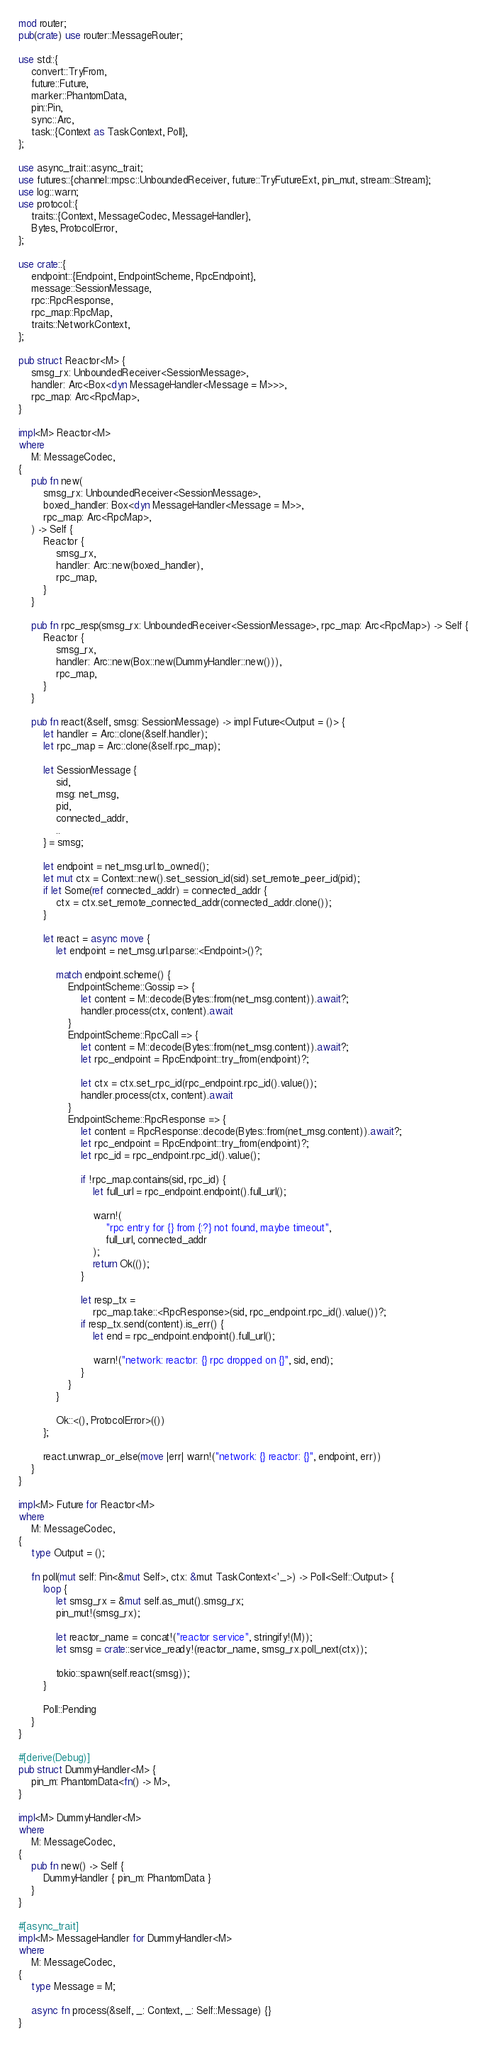Convert code to text. <code><loc_0><loc_0><loc_500><loc_500><_Rust_>mod router;
pub(crate) use router::MessageRouter;

use std::{
    convert::TryFrom,
    future::Future,
    marker::PhantomData,
    pin::Pin,
    sync::Arc,
    task::{Context as TaskContext, Poll},
};

use async_trait::async_trait;
use futures::{channel::mpsc::UnboundedReceiver, future::TryFutureExt, pin_mut, stream::Stream};
use log::warn;
use protocol::{
    traits::{Context, MessageCodec, MessageHandler},
    Bytes, ProtocolError,
};

use crate::{
    endpoint::{Endpoint, EndpointScheme, RpcEndpoint},
    message::SessionMessage,
    rpc::RpcResponse,
    rpc_map::RpcMap,
    traits::NetworkContext,
};

pub struct Reactor<M> {
    smsg_rx: UnboundedReceiver<SessionMessage>,
    handler: Arc<Box<dyn MessageHandler<Message = M>>>,
    rpc_map: Arc<RpcMap>,
}

impl<M> Reactor<M>
where
    M: MessageCodec,
{
    pub fn new(
        smsg_rx: UnboundedReceiver<SessionMessage>,
        boxed_handler: Box<dyn MessageHandler<Message = M>>,
        rpc_map: Arc<RpcMap>,
    ) -> Self {
        Reactor {
            smsg_rx,
            handler: Arc::new(boxed_handler),
            rpc_map,
        }
    }

    pub fn rpc_resp(smsg_rx: UnboundedReceiver<SessionMessage>, rpc_map: Arc<RpcMap>) -> Self {
        Reactor {
            smsg_rx,
            handler: Arc::new(Box::new(DummyHandler::new())),
            rpc_map,
        }
    }

    pub fn react(&self, smsg: SessionMessage) -> impl Future<Output = ()> {
        let handler = Arc::clone(&self.handler);
        let rpc_map = Arc::clone(&self.rpc_map);

        let SessionMessage {
            sid,
            msg: net_msg,
            pid,
            connected_addr,
            ..
        } = smsg;

        let endpoint = net_msg.url.to_owned();
        let mut ctx = Context::new().set_session_id(sid).set_remote_peer_id(pid);
        if let Some(ref connected_addr) = connected_addr {
            ctx = ctx.set_remote_connected_addr(connected_addr.clone());
        }

        let react = async move {
            let endpoint = net_msg.url.parse::<Endpoint>()?;

            match endpoint.scheme() {
                EndpointScheme::Gossip => {
                    let content = M::decode(Bytes::from(net_msg.content)).await?;
                    handler.process(ctx, content).await
                }
                EndpointScheme::RpcCall => {
                    let content = M::decode(Bytes::from(net_msg.content)).await?;
                    let rpc_endpoint = RpcEndpoint::try_from(endpoint)?;

                    let ctx = ctx.set_rpc_id(rpc_endpoint.rpc_id().value());
                    handler.process(ctx, content).await
                }
                EndpointScheme::RpcResponse => {
                    let content = RpcResponse::decode(Bytes::from(net_msg.content)).await?;
                    let rpc_endpoint = RpcEndpoint::try_from(endpoint)?;
                    let rpc_id = rpc_endpoint.rpc_id().value();

                    if !rpc_map.contains(sid, rpc_id) {
                        let full_url = rpc_endpoint.endpoint().full_url();

                        warn!(
                            "rpc entry for {} from {:?} not found, maybe timeout",
                            full_url, connected_addr
                        );
                        return Ok(());
                    }

                    let resp_tx =
                        rpc_map.take::<RpcResponse>(sid, rpc_endpoint.rpc_id().value())?;
                    if resp_tx.send(content).is_err() {
                        let end = rpc_endpoint.endpoint().full_url();

                        warn!("network: reactor: {} rpc dropped on {}", sid, end);
                    }
                }
            }

            Ok::<(), ProtocolError>(())
        };

        react.unwrap_or_else(move |err| warn!("network: {} reactor: {}", endpoint, err))
    }
}

impl<M> Future for Reactor<M>
where
    M: MessageCodec,
{
    type Output = ();

    fn poll(mut self: Pin<&mut Self>, ctx: &mut TaskContext<'_>) -> Poll<Self::Output> {
        loop {
            let smsg_rx = &mut self.as_mut().smsg_rx;
            pin_mut!(smsg_rx);

            let reactor_name = concat!("reactor service", stringify!(M));
            let smsg = crate::service_ready!(reactor_name, smsg_rx.poll_next(ctx));

            tokio::spawn(self.react(smsg));
        }

        Poll::Pending
    }
}

#[derive(Debug)]
pub struct DummyHandler<M> {
    pin_m: PhantomData<fn() -> M>,
}

impl<M> DummyHandler<M>
where
    M: MessageCodec,
{
    pub fn new() -> Self {
        DummyHandler { pin_m: PhantomData }
    }
}

#[async_trait]
impl<M> MessageHandler for DummyHandler<M>
where
    M: MessageCodec,
{
    type Message = M;

    async fn process(&self, _: Context, _: Self::Message) {}
}
</code> 